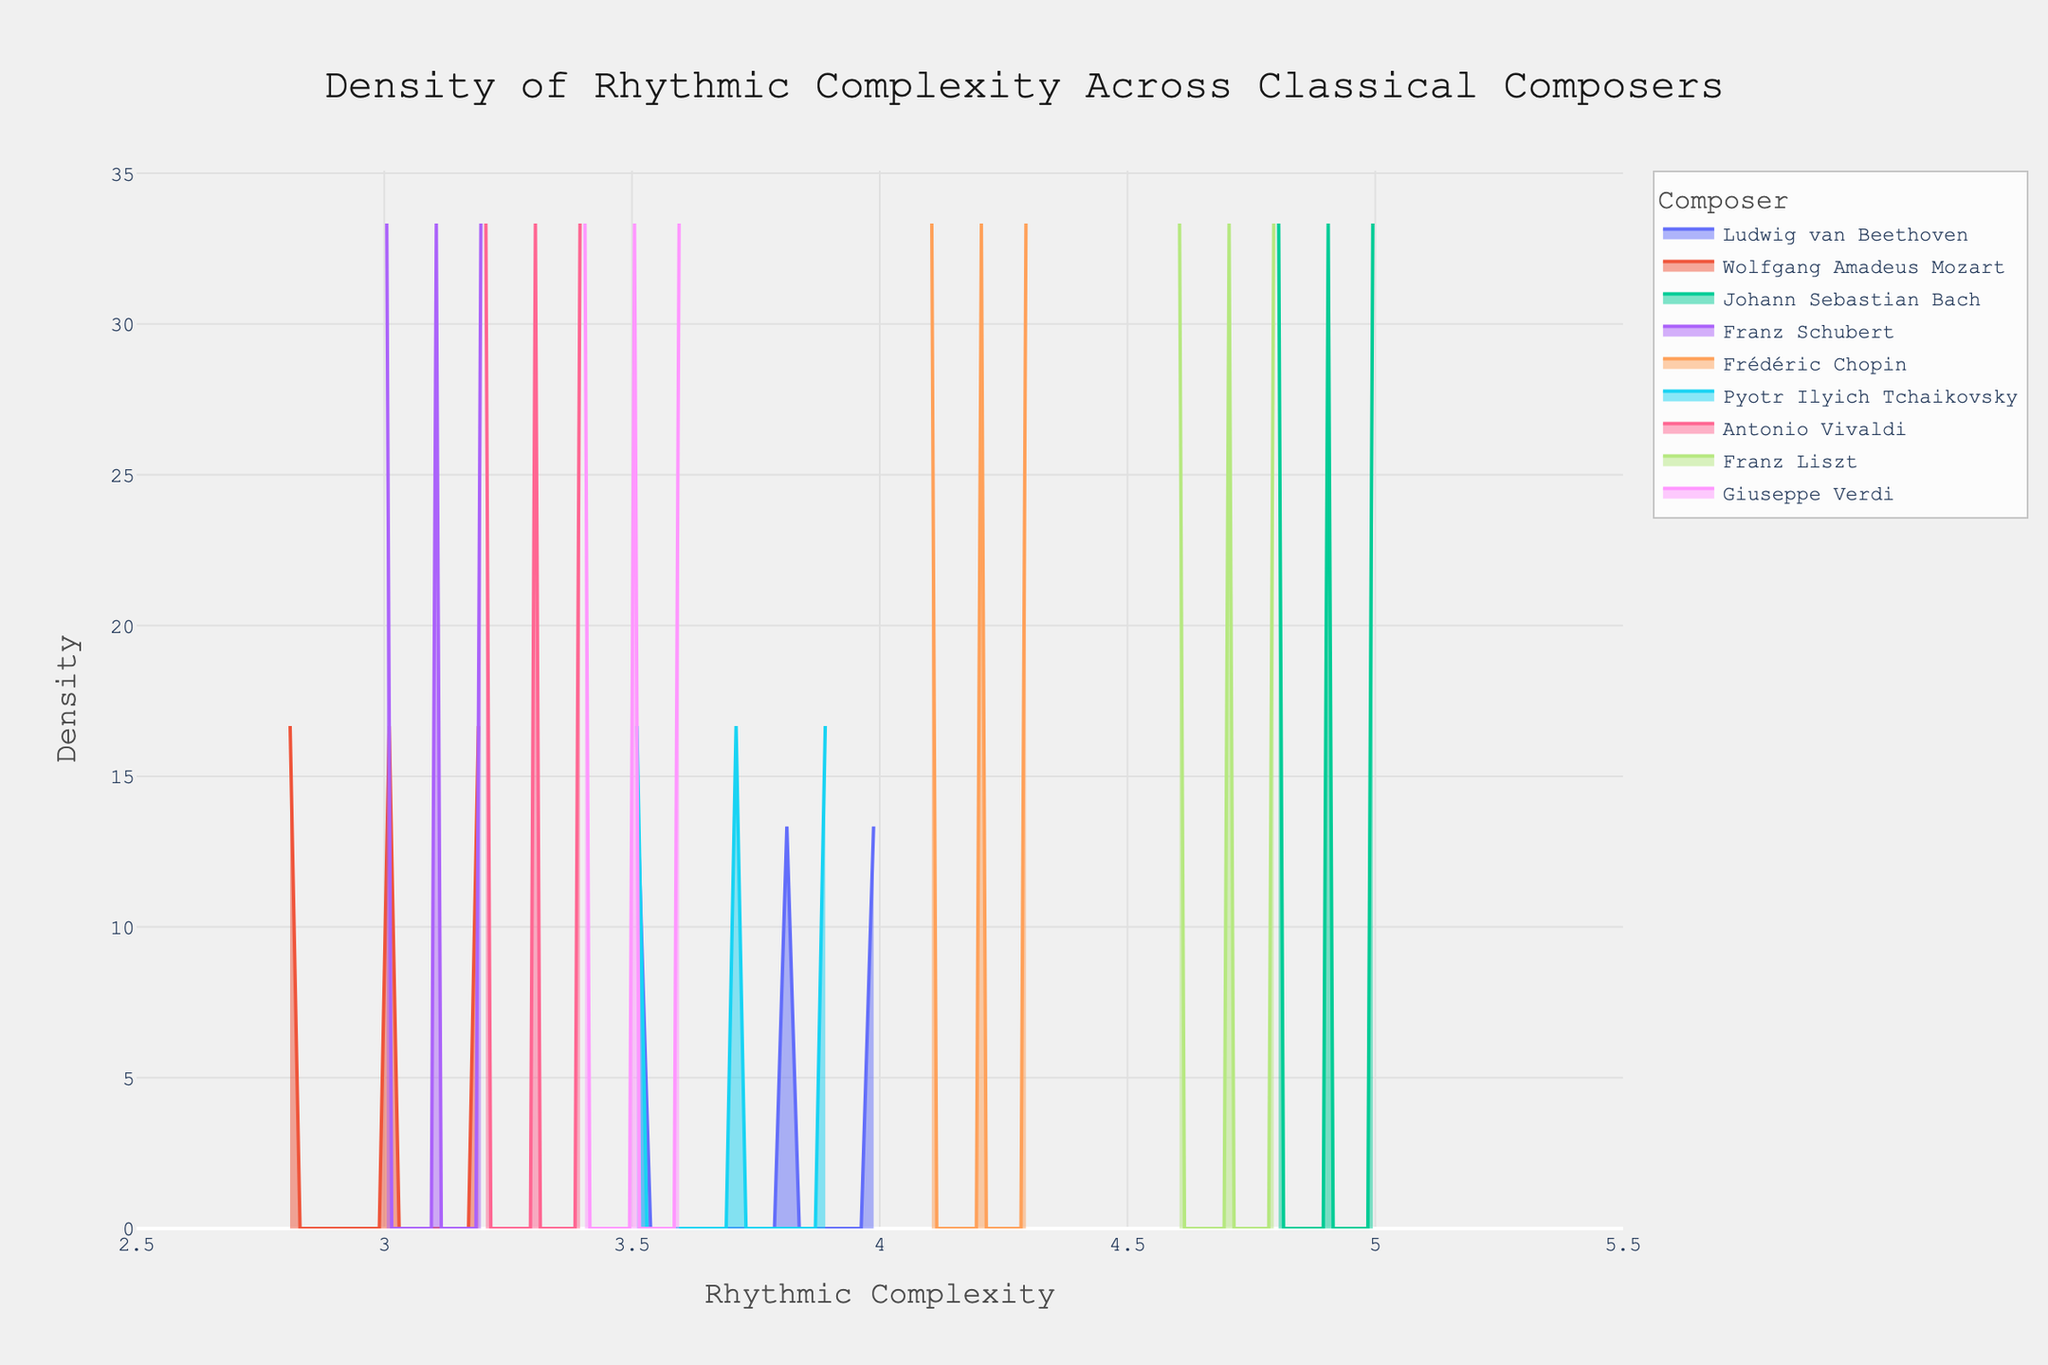What is the title of the plot? The title of the plot is located at the top center of the figure, which provides a high-level summary of the visual representation. Reading it reveals it says, "Density of Rhythmic Complexity Across Classical Composers".
Answer: Density of Rhythmic Complexity Across Classical Composers What does the x-axis represent? The x-axis label is positioned at the bottom of the figure and it provides information about what is being measured horizontally. In this plot, it reads "Rhythmic Complexity".
Answer: Rhythmic Complexity Which composer has the highest peak density? To determine the highest peak density, look for the tallest point in the figure and note which composer's density curve this peak belongs to. Bach has the highest peak density in this density plot.
Answer: Johann Sebastian Bach Between Beethoven and Tchaikovsky, who exhibits more variability in rhythmic complexity? Variability in rhythmic complexity can be inferred by the spread of the density curve. Beethoven has a more spread-out curve, indicating higher variability compared to Tchaikovsky.
Answer: Ludwig van Beethoven What is the approximate range of rhythmic complexity values for Mozart? The range can be inferred by noting where Mozart’s density curve starts and ends along the x-axis. For Mozart, the rhythmic complexity approximately ranges from 2.8 to 3.2.
Answer: 2.8 to 3.2 Compare the rhythmic complexity distributions of Bach and Chopin. Which composer has a more concentrated distribution? Compare the width of the peaks. A more concentrated distribution will have a narrower peak. Bach's peak is narrower compared to Chopin's, indicating a more concentrated distribution.
Answer: Johann Sebastian Bach What is the density value at the peak for Bach's rhythmic complexity distribution? Locate the peak of Bach's curve and read the corresponding y-axis value. The peak density value for Bach is approximately 1.0.
Answer: 1.0 Does any composer have overlapping rhythmic complexity distributions with Verdi? Check if Verdi's density curve overlaps with any other composer's curves within the same range of x-axis values. Verdi's distribution overlaps with those of Beethoven and Vivaldi.
Answer: Beethoven, Vivaldi Which composers have rhythmic complexities centered around 4.0? Look for density curves that have significant values near the 4.0 mark on the x-axis. Beethoven, Chopin, and Tchaikovsky show densities centered around 4.0.
Answer: Beethoven, Chopin, Tchaikovsky 